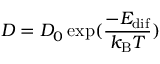<formula> <loc_0><loc_0><loc_500><loc_500>D = D _ { 0 } \exp ( \frac { - E _ { d i f } } { k _ { B } T } )</formula> 